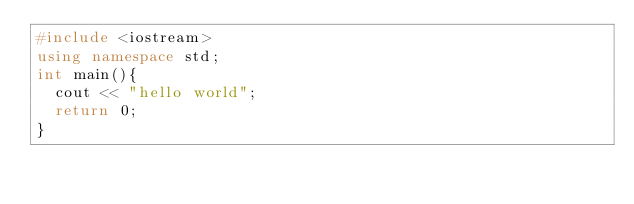Convert code to text. <code><loc_0><loc_0><loc_500><loc_500><_C++_>#include <iostream>
using namespace std;
int main(){
  cout << "hello world";
  return 0;
}
</code> 